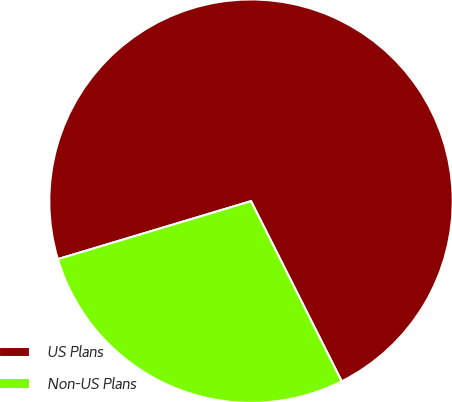<chart> <loc_0><loc_0><loc_500><loc_500><pie_chart><fcel>US Plans<fcel>Non-US Plans<nl><fcel>72.22%<fcel>27.78%<nl></chart> 